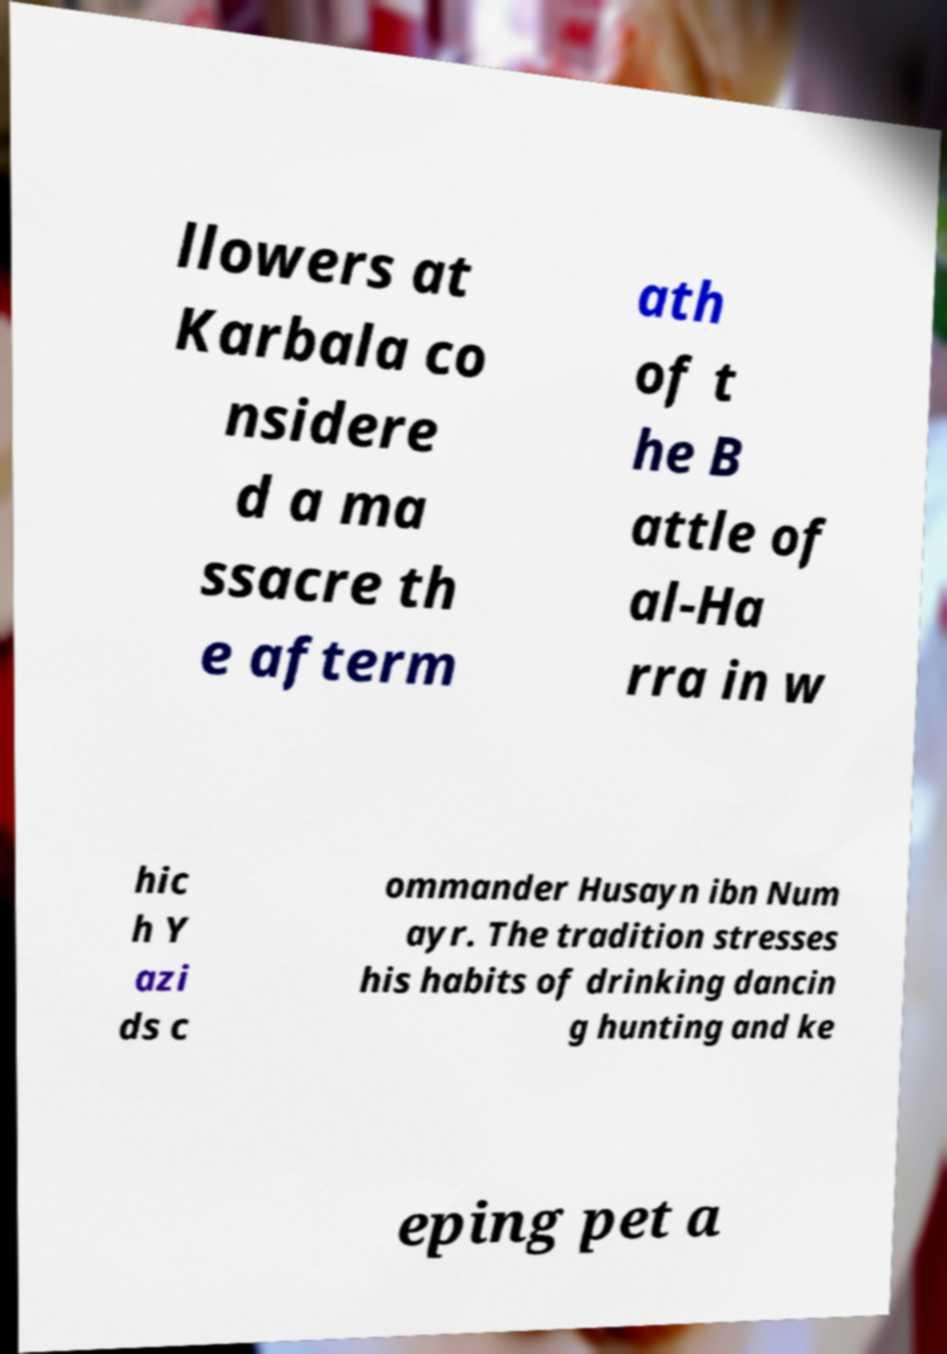Please read and relay the text visible in this image. What does it say? llowers at Karbala co nsidere d a ma ssacre th e afterm ath of t he B attle of al-Ha rra in w hic h Y azi ds c ommander Husayn ibn Num ayr. The tradition stresses his habits of drinking dancin g hunting and ke eping pet a 